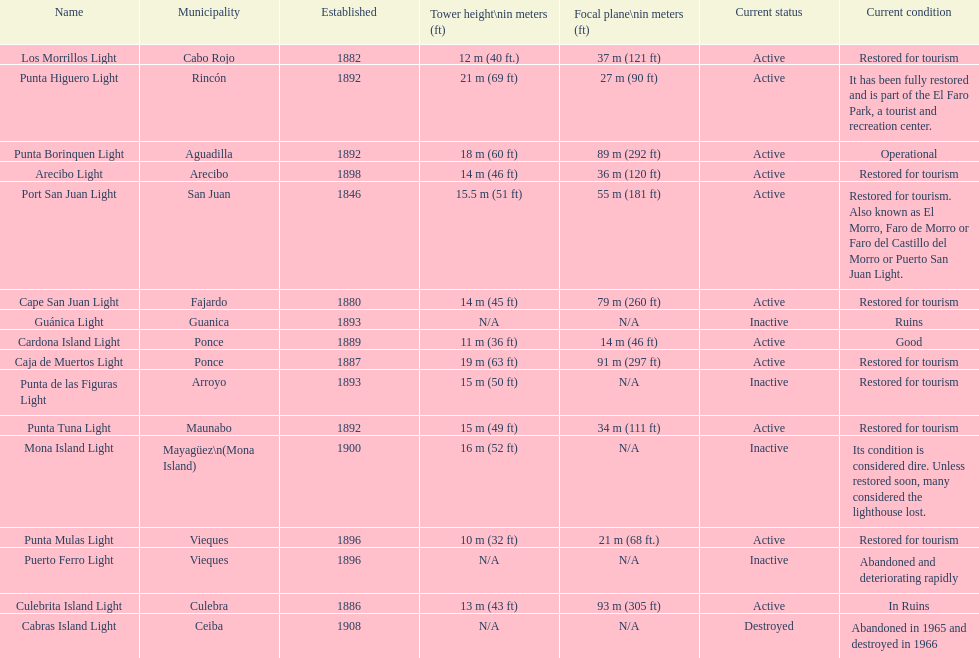Number of lighthouses that begin with the letter p 7. 